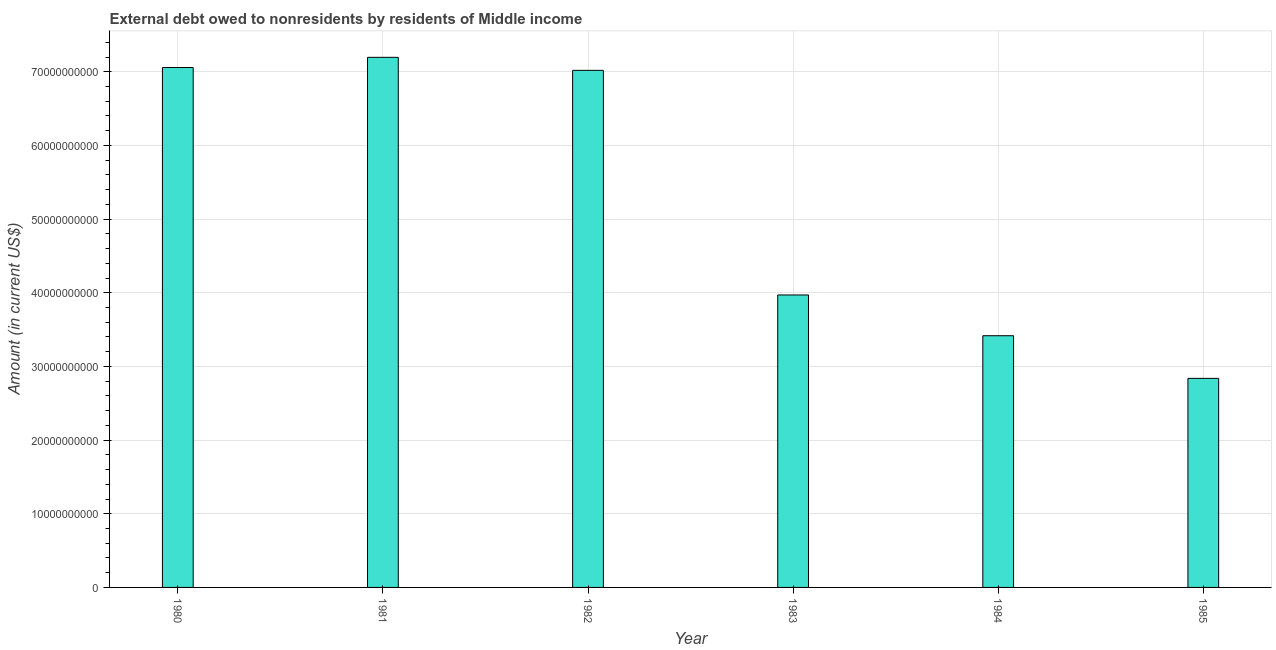What is the title of the graph?
Offer a terse response. External debt owed to nonresidents by residents of Middle income. What is the label or title of the X-axis?
Provide a short and direct response. Year. What is the label or title of the Y-axis?
Ensure brevity in your answer.  Amount (in current US$). What is the debt in 1981?
Keep it short and to the point. 7.20e+1. Across all years, what is the maximum debt?
Offer a very short reply. 7.20e+1. Across all years, what is the minimum debt?
Keep it short and to the point. 2.84e+1. In which year was the debt maximum?
Give a very brief answer. 1981. What is the sum of the debt?
Your answer should be very brief. 3.15e+11. What is the difference between the debt in 1980 and 1982?
Your answer should be very brief. 3.85e+08. What is the average debt per year?
Provide a succinct answer. 5.25e+1. What is the median debt?
Provide a succinct answer. 5.49e+1. In how many years, is the debt greater than 34000000000 US$?
Give a very brief answer. 5. What is the ratio of the debt in 1981 to that in 1983?
Keep it short and to the point. 1.81. What is the difference between the highest and the second highest debt?
Your response must be concise. 1.38e+09. Is the sum of the debt in 1980 and 1981 greater than the maximum debt across all years?
Your response must be concise. Yes. What is the difference between the highest and the lowest debt?
Ensure brevity in your answer.  4.36e+1. In how many years, is the debt greater than the average debt taken over all years?
Offer a terse response. 3. How many bars are there?
Offer a terse response. 6. What is the difference between two consecutive major ticks on the Y-axis?
Provide a succinct answer. 1.00e+1. Are the values on the major ticks of Y-axis written in scientific E-notation?
Make the answer very short. No. What is the Amount (in current US$) in 1980?
Give a very brief answer. 7.06e+1. What is the Amount (in current US$) in 1981?
Your response must be concise. 7.20e+1. What is the Amount (in current US$) of 1982?
Provide a short and direct response. 7.02e+1. What is the Amount (in current US$) of 1983?
Provide a succinct answer. 3.97e+1. What is the Amount (in current US$) in 1984?
Ensure brevity in your answer.  3.42e+1. What is the Amount (in current US$) of 1985?
Provide a short and direct response. 2.84e+1. What is the difference between the Amount (in current US$) in 1980 and 1981?
Provide a short and direct response. -1.38e+09. What is the difference between the Amount (in current US$) in 1980 and 1982?
Offer a terse response. 3.85e+08. What is the difference between the Amount (in current US$) in 1980 and 1983?
Keep it short and to the point. 3.09e+1. What is the difference between the Amount (in current US$) in 1980 and 1984?
Offer a terse response. 3.64e+1. What is the difference between the Amount (in current US$) in 1980 and 1985?
Give a very brief answer. 4.22e+1. What is the difference between the Amount (in current US$) in 1981 and 1982?
Keep it short and to the point. 1.77e+09. What is the difference between the Amount (in current US$) in 1981 and 1983?
Provide a short and direct response. 3.23e+1. What is the difference between the Amount (in current US$) in 1981 and 1984?
Provide a succinct answer. 3.78e+1. What is the difference between the Amount (in current US$) in 1981 and 1985?
Make the answer very short. 4.36e+1. What is the difference between the Amount (in current US$) in 1982 and 1983?
Provide a succinct answer. 3.05e+1. What is the difference between the Amount (in current US$) in 1982 and 1984?
Keep it short and to the point. 3.60e+1. What is the difference between the Amount (in current US$) in 1982 and 1985?
Provide a short and direct response. 4.18e+1. What is the difference between the Amount (in current US$) in 1983 and 1984?
Ensure brevity in your answer.  5.53e+09. What is the difference between the Amount (in current US$) in 1983 and 1985?
Your answer should be very brief. 1.13e+1. What is the difference between the Amount (in current US$) in 1984 and 1985?
Offer a terse response. 5.79e+09. What is the ratio of the Amount (in current US$) in 1980 to that in 1981?
Your response must be concise. 0.98. What is the ratio of the Amount (in current US$) in 1980 to that in 1982?
Offer a very short reply. 1. What is the ratio of the Amount (in current US$) in 1980 to that in 1983?
Offer a very short reply. 1.78. What is the ratio of the Amount (in current US$) in 1980 to that in 1984?
Provide a short and direct response. 2.07. What is the ratio of the Amount (in current US$) in 1980 to that in 1985?
Make the answer very short. 2.49. What is the ratio of the Amount (in current US$) in 1981 to that in 1982?
Ensure brevity in your answer.  1.02. What is the ratio of the Amount (in current US$) in 1981 to that in 1983?
Give a very brief answer. 1.81. What is the ratio of the Amount (in current US$) in 1981 to that in 1984?
Make the answer very short. 2.11. What is the ratio of the Amount (in current US$) in 1981 to that in 1985?
Give a very brief answer. 2.54. What is the ratio of the Amount (in current US$) in 1982 to that in 1983?
Offer a terse response. 1.77. What is the ratio of the Amount (in current US$) in 1982 to that in 1984?
Offer a terse response. 2.05. What is the ratio of the Amount (in current US$) in 1982 to that in 1985?
Ensure brevity in your answer.  2.47. What is the ratio of the Amount (in current US$) in 1983 to that in 1984?
Offer a terse response. 1.16. What is the ratio of the Amount (in current US$) in 1983 to that in 1985?
Keep it short and to the point. 1.4. What is the ratio of the Amount (in current US$) in 1984 to that in 1985?
Make the answer very short. 1.2. 